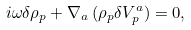<formula> <loc_0><loc_0><loc_500><loc_500>i \omega \delta \rho _ { p } + \nabla _ { a } \, ( \rho _ { p } \delta V _ { p } ^ { a } ) = 0 ,</formula> 